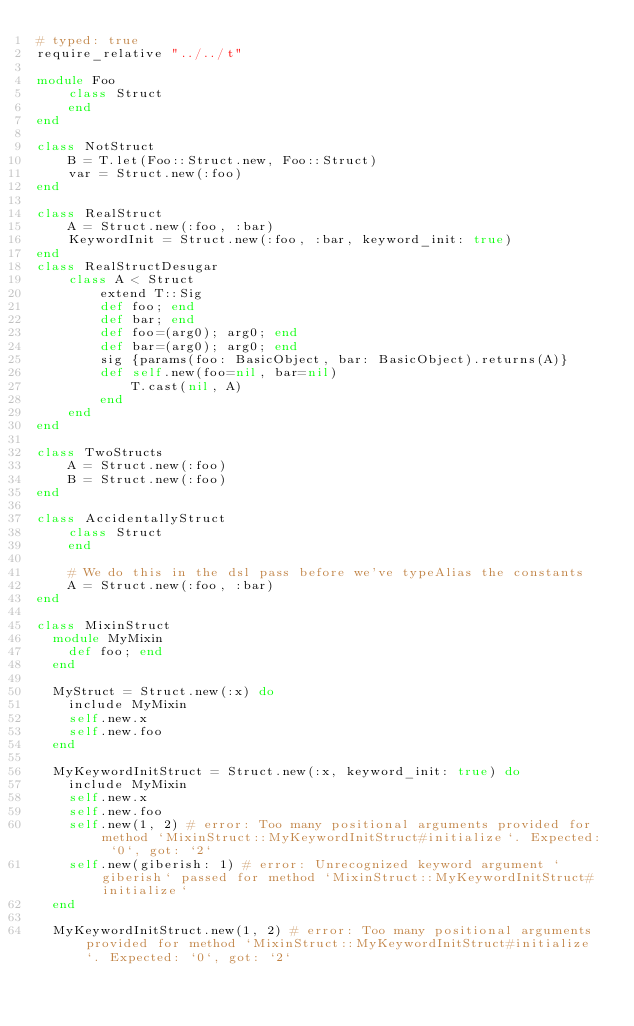<code> <loc_0><loc_0><loc_500><loc_500><_Ruby_># typed: true
require_relative "../../t"

module Foo
    class Struct
    end
end

class NotStruct
    B = T.let(Foo::Struct.new, Foo::Struct)
    var = Struct.new(:foo)
end

class RealStruct
    A = Struct.new(:foo, :bar)
    KeywordInit = Struct.new(:foo, :bar, keyword_init: true)
end
class RealStructDesugar
    class A < Struct
        extend T::Sig
        def foo; end
        def bar; end
        def foo=(arg0); arg0; end
        def bar=(arg0); arg0; end
        sig {params(foo: BasicObject, bar: BasicObject).returns(A)}
        def self.new(foo=nil, bar=nil)
            T.cast(nil, A)
        end
    end
end

class TwoStructs
    A = Struct.new(:foo)
    B = Struct.new(:foo)
end

class AccidentallyStruct
    class Struct
    end

    # We do this in the dsl pass before we've typeAlias the constants
    A = Struct.new(:foo, :bar)
end

class MixinStruct
  module MyMixin
    def foo; end
  end

  MyStruct = Struct.new(:x) do
    include MyMixin
    self.new.x
    self.new.foo
  end

  MyKeywordInitStruct = Struct.new(:x, keyword_init: true) do
    include MyMixin
    self.new.x
    self.new.foo
    self.new(1, 2) # error: Too many positional arguments provided for method `MixinStruct::MyKeywordInitStruct#initialize`. Expected: `0`, got: `2`
    self.new(giberish: 1) # error: Unrecognized keyword argument `giberish` passed for method `MixinStruct::MyKeywordInitStruct#initialize`
  end

  MyKeywordInitStruct.new(1, 2) # error: Too many positional arguments provided for method `MixinStruct::MyKeywordInitStruct#initialize`. Expected: `0`, got: `2`</code> 